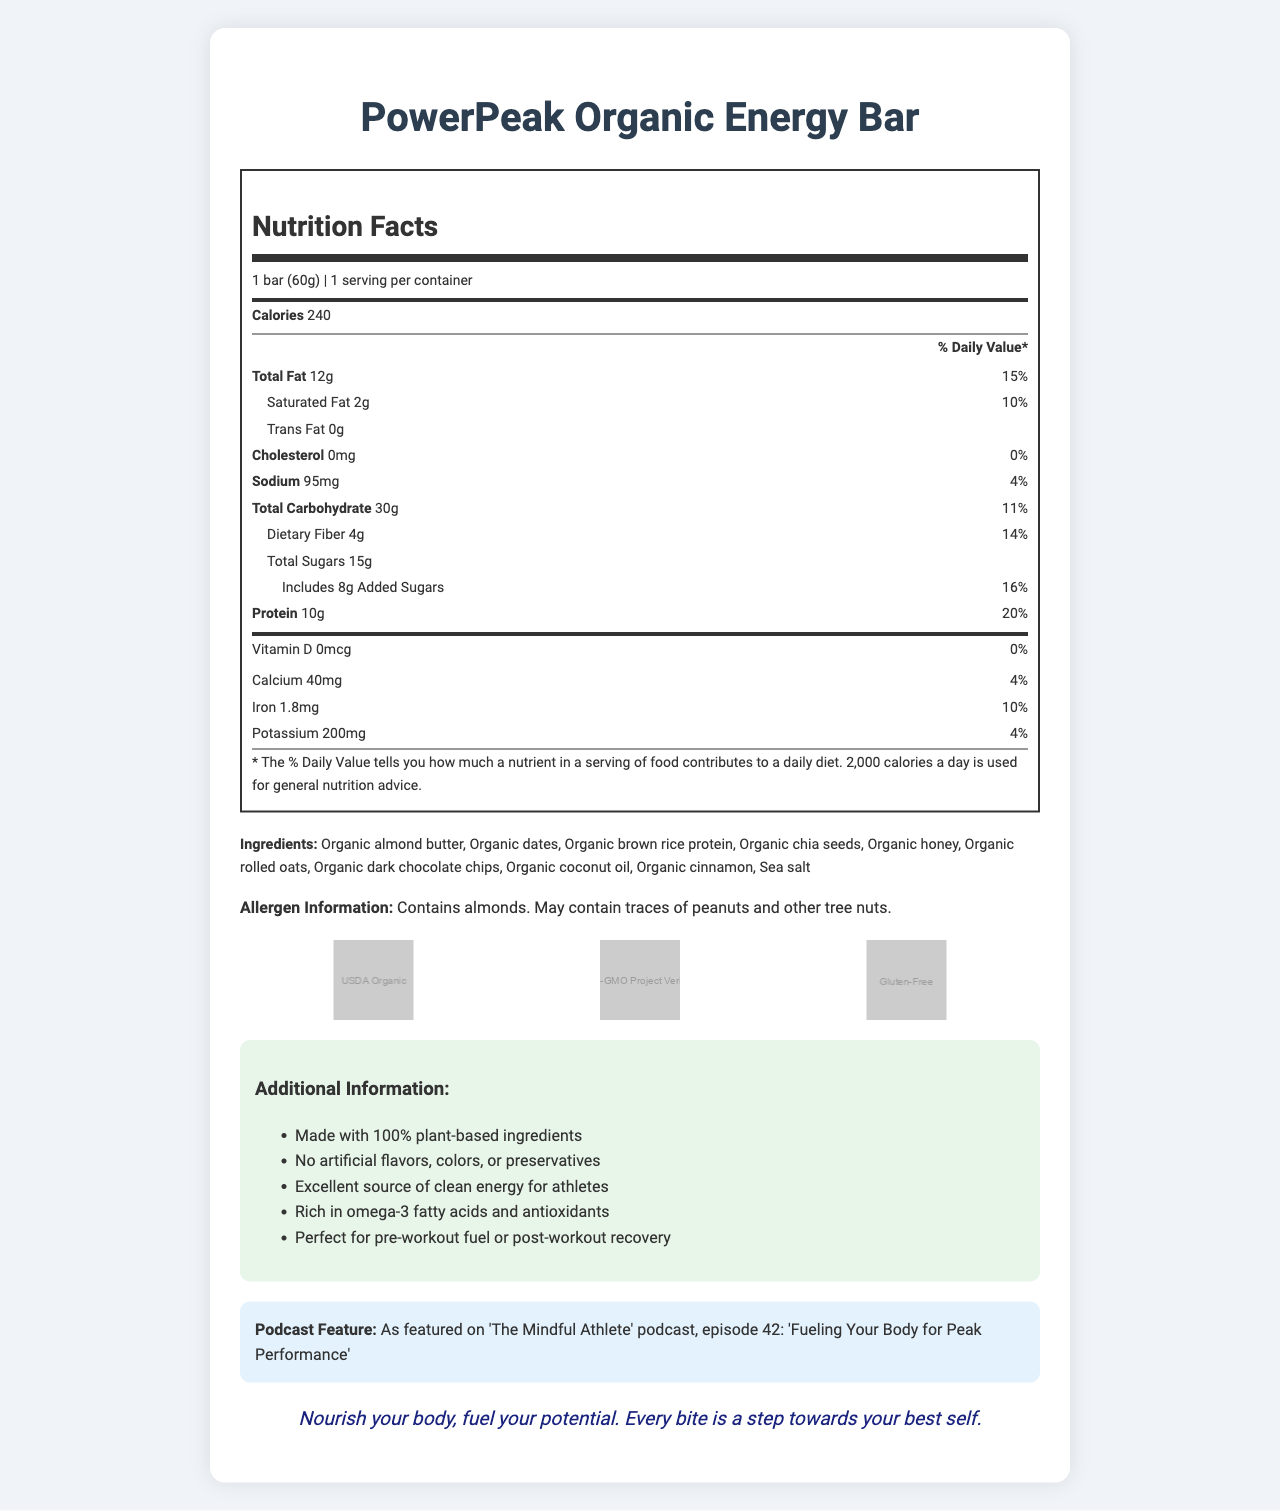what is the serving size of the PowerPeak Organic Energy Bar? The serving size is listed at the top of the nutrition facts section: "1 bar (60g)."
Answer: 1 bar (60g) how many calories does one PowerPeak Organic Energy Bar contain? The calorie count is prominently displayed under the serving size and servings per container: "Calories 240."
Answer: 240 what percentage of the daily value is the total fat? The percentage of daily value for total fat is shown next to the total fat amount: "Total Fat 12g 15%."
Answer: 15% how much protein is in the PowerPeak Organic Energy Bar? The protein amount is listed under the total carbohydrate information: "Protein 10g."
Answer: 10g what is the total carbohydrate amount per serving? The total carbohydrate amount is shown under sodium: "Total Carbohydrate 30g."
Answer: 30g which ingredient is listed first in the ingredients list? The ingredients list starts with "Organic almond butter."
Answer: Organic almond butter what certifications does the PowerPeak Organic Energy Bar have? These certifications are listed in the certifications section with corresponding images.
Answer: USDA Organic, Non-GMO Project Verified, Gluten-Free what does the podcast tie-in mention? The podcast tie-in information is given in a separate section: "As featured on 'The Mindful Athlete' podcast, episode 42: 'Fueling Your Body for Peak Performance.'"
Answer: As featured on 'The Mindful Athlete' podcast, episode 42: 'Fueling Your Body for Peak Performance' how much dietary fiber does the PowerPeak Organic Energy Bar provide? Dietary fiber amount is listed under total carbohydrate: "Dietary Fiber 4g 14%."
Answer: 4g how many grams of added sugars are in the PowerPeak Organic Energy Bar? The amount of added sugars is shown under the total sugars entry: "Includes 8g Added Sugars 16%."
Answer: 8g which of the following is NOT listed as an ingredient? A. Organic almond butter B. Organic apple slices C. Sea salt The ingredients list includes "Organic almond butter" and "Sea salt," but "Organic apple slices" are not mentioned.
Answer: B this PowerPeak Organic Energy Bar contains artificial flavors and colors. True or False? In the additional info section, it's stated "No artificial flavors, colors, or preservatives."
Answer: False which of the following is a health benefit mentioned in the additional information? I. Excellent source of clean energy for athletes II. Contains caffeine III. High in cholesterol IV. Rich in omega-3 fatty acids and antioxidants "Excellent source of clean energy for athletes" and "Rich in omega-3 fatty acids and antioxidants" are mentioned in the additional information section.
Answer: I and IV how would you summarize the information provided in this document? The document contains comprehensive information about the PowerPeak Organic Energy Bar's nutrition facts, ingredients, certifications, health benefits, and additional unique selling points like its podcast feature and motivational message.
Answer: The document presents the nutrition facts and additional details for the PowerPeak Organic Energy Bar. It contains 240 calories per serving, 12g of fat, 30g of carbohydrates, 10g of protein, and is rich in dietary fiber. The ingredients are all organic, and the product is certified USDA Organic, Non-GMO Project Verified, and Gluten-Free. The bar is designed to provide clean energy for athletes and is featured in a wellness podcast. The document also includes a self-help message encouraging users to nourish their bodies for optimal performance. what is the specific date of production for the PowerPeak Organic Energy Bar? The nutrition facts label and additional information provided do not include any details about the production date.
Answer: Cannot be determined 